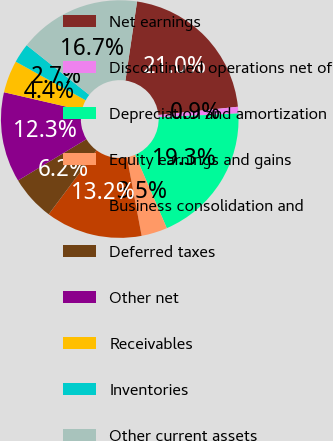Convert chart. <chart><loc_0><loc_0><loc_500><loc_500><pie_chart><fcel>Net earnings<fcel>Discontinued operations net of<fcel>Depreciation and amortization<fcel>Equity earnings and gains<fcel>Business consolidation and<fcel>Deferred taxes<fcel>Other net<fcel>Receivables<fcel>Inventories<fcel>Other current assets<nl><fcel>21.02%<fcel>0.9%<fcel>19.27%<fcel>3.53%<fcel>13.15%<fcel>6.15%<fcel>12.27%<fcel>4.4%<fcel>2.65%<fcel>16.65%<nl></chart> 